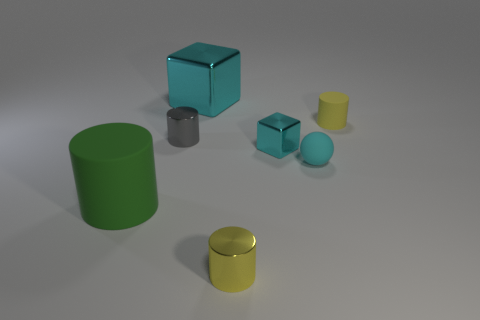Does the big cylinder have the same color as the tiny block?
Your answer should be compact. No. There is a tiny shiny thing that is in front of the green thing; does it have the same shape as the large cyan thing?
Provide a succinct answer. No. How many yellow cylinders are both on the right side of the matte ball and in front of the tiny gray thing?
Ensure brevity in your answer.  0. What is the material of the small sphere?
Give a very brief answer. Rubber. Is there any other thing of the same color as the matte sphere?
Make the answer very short. Yes. Is the tiny cyan sphere made of the same material as the small cyan block?
Keep it short and to the point. No. How many tiny yellow cylinders are to the left of the cube behind the matte cylinder to the right of the big green rubber cylinder?
Make the answer very short. 0. How many big cyan metal blocks are there?
Offer a very short reply. 1. Are there fewer yellow matte objects that are in front of the ball than tiny yellow matte cylinders to the left of the gray metal object?
Your answer should be compact. No. Are there fewer gray objects right of the rubber sphere than gray things?
Keep it short and to the point. Yes. 